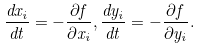Convert formula to latex. <formula><loc_0><loc_0><loc_500><loc_500>\frac { d x _ { i } } { d t } = - \frac { \partial f } { \partial x _ { i } } , \frac { d y _ { i } } { d t } = - \frac { \partial f } { \partial y _ { i } } .</formula> 